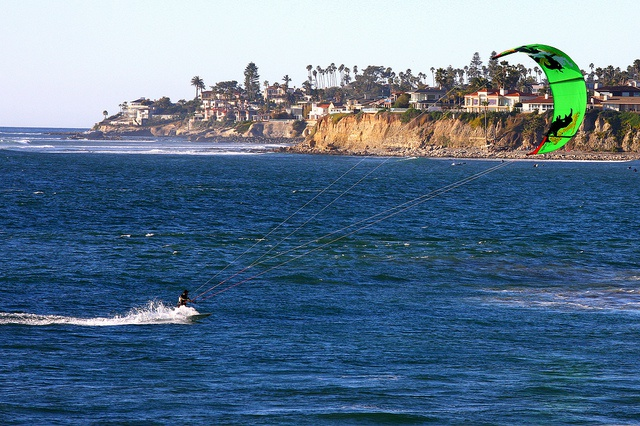Describe the objects in this image and their specific colors. I can see kite in white, black, and lime tones, surfboard in white, lightgray, black, gray, and navy tones, people in white, black, gray, maroon, and darkblue tones, and people in white, black, navy, and blue tones in this image. 